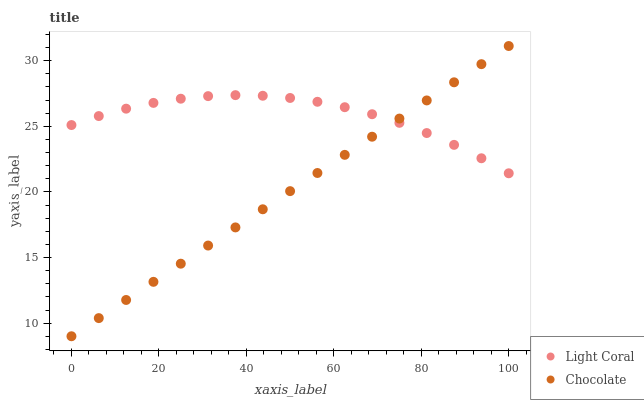Does Chocolate have the minimum area under the curve?
Answer yes or no. Yes. Does Light Coral have the maximum area under the curve?
Answer yes or no. Yes. Does Chocolate have the maximum area under the curve?
Answer yes or no. No. Is Chocolate the smoothest?
Answer yes or no. Yes. Is Light Coral the roughest?
Answer yes or no. Yes. Is Chocolate the roughest?
Answer yes or no. No. Does Chocolate have the lowest value?
Answer yes or no. Yes. Does Chocolate have the highest value?
Answer yes or no. Yes. Does Chocolate intersect Light Coral?
Answer yes or no. Yes. Is Chocolate less than Light Coral?
Answer yes or no. No. Is Chocolate greater than Light Coral?
Answer yes or no. No. 